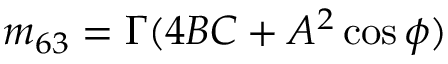Convert formula to latex. <formula><loc_0><loc_0><loc_500><loc_500>m _ { 6 3 } = \Gamma ( 4 B C + A ^ { 2 } \cos \phi )</formula> 